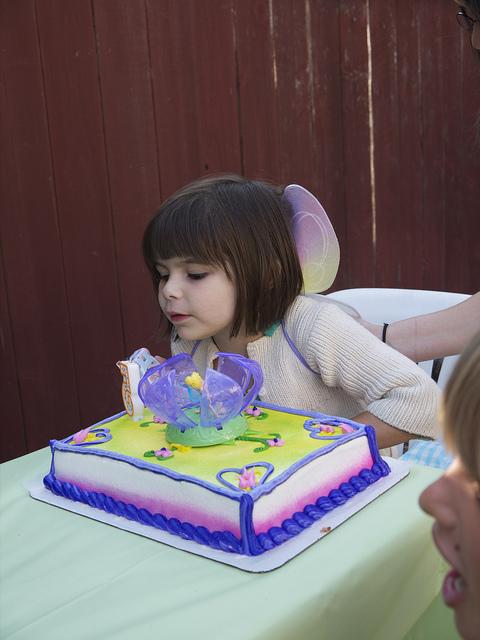What color is the frosting?
Keep it brief. Yellow, white, and purple. Can this kid eat the whole cake in 10 minutes?
Concise answer only. No. What is this girl doing?
Write a very short answer. Blowing out candle. What song was being sung while this picture was taken?
Write a very short answer. Happy birthday. What is in front of this child?
Write a very short answer. Cake. What is she doing?
Write a very short answer. Blowing out candle. Are the girls outside?
Quick response, please. Yes. Is the child old enough to cut the cake?
Quick response, please. No. What color is the little girl's shirt?
Quick response, please. White. 